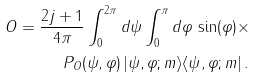<formula> <loc_0><loc_0><loc_500><loc_500>O = \frac { 2 j + 1 } { 4 \pi } \int _ { 0 } ^ { 2 \pi } d \psi \int _ { 0 } ^ { \pi } d \varphi \, \sin ( \varphi ) \times \\ P _ { O } ( \psi , \varphi ) \, | \psi , \varphi ; m \rangle \langle \psi , \varphi ; m | \, .</formula> 